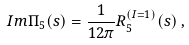Convert formula to latex. <formula><loc_0><loc_0><loc_500><loc_500>I m \Pi _ { 5 } ( s ) = \frac { 1 } { 1 2 \pi } R _ { 5 } ^ { ( I = 1 ) } ( s ) \, ,</formula> 